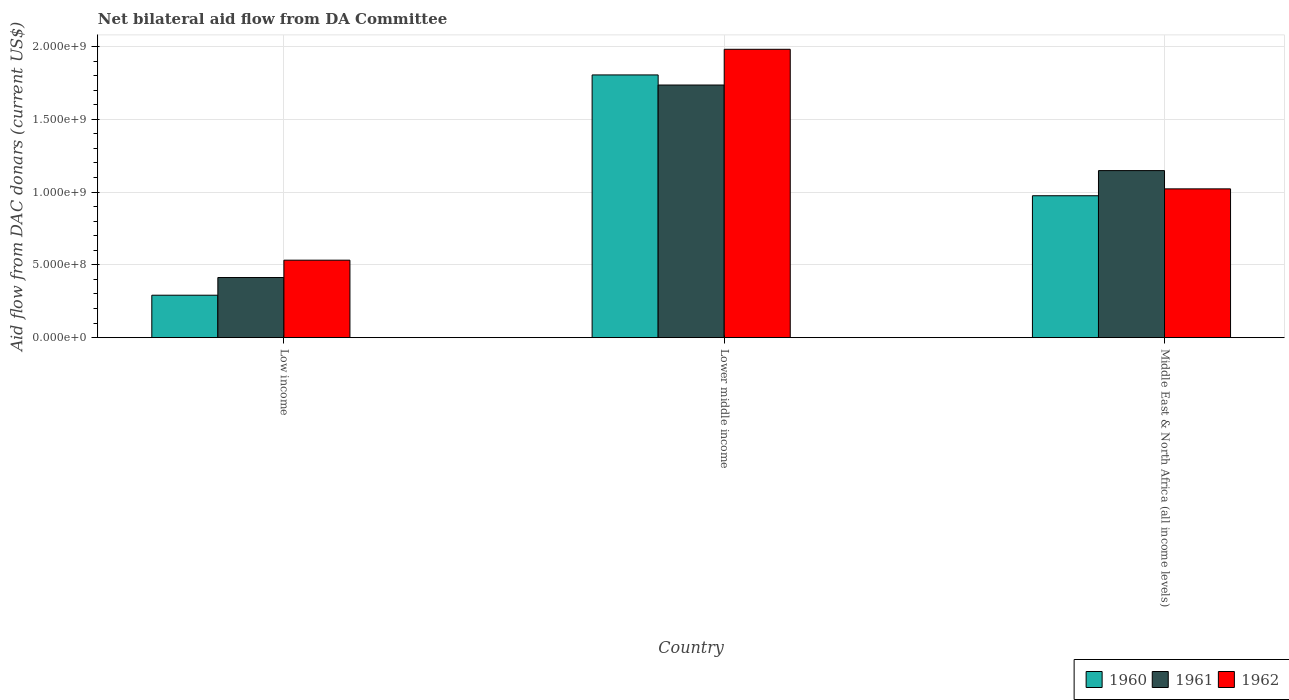How many groups of bars are there?
Your answer should be very brief. 3. How many bars are there on the 2nd tick from the right?
Offer a terse response. 3. What is the label of the 1st group of bars from the left?
Provide a succinct answer. Low income. What is the aid flow in in 1961 in Lower middle income?
Your response must be concise. 1.74e+09. Across all countries, what is the maximum aid flow in in 1962?
Provide a succinct answer. 1.98e+09. Across all countries, what is the minimum aid flow in in 1960?
Provide a short and direct response. 2.92e+08. In which country was the aid flow in in 1960 maximum?
Your answer should be compact. Lower middle income. In which country was the aid flow in in 1962 minimum?
Provide a short and direct response. Low income. What is the total aid flow in in 1962 in the graph?
Give a very brief answer. 3.53e+09. What is the difference between the aid flow in in 1961 in Lower middle income and that in Middle East & North Africa (all income levels)?
Ensure brevity in your answer.  5.88e+08. What is the difference between the aid flow in in 1962 in Low income and the aid flow in in 1961 in Lower middle income?
Make the answer very short. -1.20e+09. What is the average aid flow in in 1960 per country?
Your answer should be very brief. 1.02e+09. What is the difference between the aid flow in of/in 1962 and aid flow in of/in 1961 in Lower middle income?
Provide a succinct answer. 2.45e+08. What is the ratio of the aid flow in in 1962 in Lower middle income to that in Middle East & North Africa (all income levels)?
Offer a very short reply. 1.94. Is the aid flow in in 1961 in Low income less than that in Middle East & North Africa (all income levels)?
Give a very brief answer. Yes. What is the difference between the highest and the second highest aid flow in in 1960?
Keep it short and to the point. 8.30e+08. What is the difference between the highest and the lowest aid flow in in 1962?
Make the answer very short. 1.45e+09. What does the 2nd bar from the left in Middle East & North Africa (all income levels) represents?
Keep it short and to the point. 1961. What does the 2nd bar from the right in Lower middle income represents?
Keep it short and to the point. 1961. Is it the case that in every country, the sum of the aid flow in in 1962 and aid flow in in 1960 is greater than the aid flow in in 1961?
Provide a short and direct response. Yes. How many bars are there?
Your answer should be compact. 9. Are all the bars in the graph horizontal?
Offer a terse response. No. What is the difference between two consecutive major ticks on the Y-axis?
Your answer should be compact. 5.00e+08. Are the values on the major ticks of Y-axis written in scientific E-notation?
Make the answer very short. Yes. Does the graph contain any zero values?
Keep it short and to the point. No. Where does the legend appear in the graph?
Provide a short and direct response. Bottom right. How many legend labels are there?
Give a very brief answer. 3. What is the title of the graph?
Give a very brief answer. Net bilateral aid flow from DA Committee. What is the label or title of the Y-axis?
Keep it short and to the point. Aid flow from DAC donars (current US$). What is the Aid flow from DAC donars (current US$) in 1960 in Low income?
Your answer should be compact. 2.92e+08. What is the Aid flow from DAC donars (current US$) in 1961 in Low income?
Make the answer very short. 4.13e+08. What is the Aid flow from DAC donars (current US$) in 1962 in Low income?
Give a very brief answer. 5.32e+08. What is the Aid flow from DAC donars (current US$) in 1960 in Lower middle income?
Offer a very short reply. 1.80e+09. What is the Aid flow from DAC donars (current US$) of 1961 in Lower middle income?
Offer a very short reply. 1.74e+09. What is the Aid flow from DAC donars (current US$) in 1962 in Lower middle income?
Your answer should be compact. 1.98e+09. What is the Aid flow from DAC donars (current US$) in 1960 in Middle East & North Africa (all income levels)?
Make the answer very short. 9.75e+08. What is the Aid flow from DAC donars (current US$) in 1961 in Middle East & North Africa (all income levels)?
Offer a very short reply. 1.15e+09. What is the Aid flow from DAC donars (current US$) of 1962 in Middle East & North Africa (all income levels)?
Your response must be concise. 1.02e+09. Across all countries, what is the maximum Aid flow from DAC donars (current US$) in 1960?
Your answer should be compact. 1.80e+09. Across all countries, what is the maximum Aid flow from DAC donars (current US$) in 1961?
Your answer should be very brief. 1.74e+09. Across all countries, what is the maximum Aid flow from DAC donars (current US$) in 1962?
Offer a very short reply. 1.98e+09. Across all countries, what is the minimum Aid flow from DAC donars (current US$) in 1960?
Keep it short and to the point. 2.92e+08. Across all countries, what is the minimum Aid flow from DAC donars (current US$) of 1961?
Your answer should be very brief. 4.13e+08. Across all countries, what is the minimum Aid flow from DAC donars (current US$) in 1962?
Provide a short and direct response. 5.32e+08. What is the total Aid flow from DAC donars (current US$) of 1960 in the graph?
Your response must be concise. 3.07e+09. What is the total Aid flow from DAC donars (current US$) in 1961 in the graph?
Ensure brevity in your answer.  3.30e+09. What is the total Aid flow from DAC donars (current US$) of 1962 in the graph?
Provide a succinct answer. 3.53e+09. What is the difference between the Aid flow from DAC donars (current US$) in 1960 in Low income and that in Lower middle income?
Your answer should be compact. -1.51e+09. What is the difference between the Aid flow from DAC donars (current US$) of 1961 in Low income and that in Lower middle income?
Ensure brevity in your answer.  -1.32e+09. What is the difference between the Aid flow from DAC donars (current US$) in 1962 in Low income and that in Lower middle income?
Ensure brevity in your answer.  -1.45e+09. What is the difference between the Aid flow from DAC donars (current US$) of 1960 in Low income and that in Middle East & North Africa (all income levels)?
Your response must be concise. -6.83e+08. What is the difference between the Aid flow from DAC donars (current US$) in 1961 in Low income and that in Middle East & North Africa (all income levels)?
Your response must be concise. -7.34e+08. What is the difference between the Aid flow from DAC donars (current US$) in 1962 in Low income and that in Middle East & North Africa (all income levels)?
Keep it short and to the point. -4.90e+08. What is the difference between the Aid flow from DAC donars (current US$) in 1960 in Lower middle income and that in Middle East & North Africa (all income levels)?
Your answer should be compact. 8.30e+08. What is the difference between the Aid flow from DAC donars (current US$) in 1961 in Lower middle income and that in Middle East & North Africa (all income levels)?
Your answer should be very brief. 5.88e+08. What is the difference between the Aid flow from DAC donars (current US$) in 1962 in Lower middle income and that in Middle East & North Africa (all income levels)?
Your answer should be very brief. 9.59e+08. What is the difference between the Aid flow from DAC donars (current US$) of 1960 in Low income and the Aid flow from DAC donars (current US$) of 1961 in Lower middle income?
Ensure brevity in your answer.  -1.44e+09. What is the difference between the Aid flow from DAC donars (current US$) in 1960 in Low income and the Aid flow from DAC donars (current US$) in 1962 in Lower middle income?
Provide a short and direct response. -1.69e+09. What is the difference between the Aid flow from DAC donars (current US$) in 1961 in Low income and the Aid flow from DAC donars (current US$) in 1962 in Lower middle income?
Give a very brief answer. -1.57e+09. What is the difference between the Aid flow from DAC donars (current US$) in 1960 in Low income and the Aid flow from DAC donars (current US$) in 1961 in Middle East & North Africa (all income levels)?
Keep it short and to the point. -8.56e+08. What is the difference between the Aid flow from DAC donars (current US$) in 1960 in Low income and the Aid flow from DAC donars (current US$) in 1962 in Middle East & North Africa (all income levels)?
Provide a succinct answer. -7.30e+08. What is the difference between the Aid flow from DAC donars (current US$) in 1961 in Low income and the Aid flow from DAC donars (current US$) in 1962 in Middle East & North Africa (all income levels)?
Your response must be concise. -6.09e+08. What is the difference between the Aid flow from DAC donars (current US$) of 1960 in Lower middle income and the Aid flow from DAC donars (current US$) of 1961 in Middle East & North Africa (all income levels)?
Offer a terse response. 6.57e+08. What is the difference between the Aid flow from DAC donars (current US$) in 1960 in Lower middle income and the Aid flow from DAC donars (current US$) in 1962 in Middle East & North Africa (all income levels)?
Your answer should be very brief. 7.83e+08. What is the difference between the Aid flow from DAC donars (current US$) in 1961 in Lower middle income and the Aid flow from DAC donars (current US$) in 1962 in Middle East & North Africa (all income levels)?
Provide a short and direct response. 7.13e+08. What is the average Aid flow from DAC donars (current US$) in 1960 per country?
Your answer should be very brief. 1.02e+09. What is the average Aid flow from DAC donars (current US$) in 1961 per country?
Provide a succinct answer. 1.10e+09. What is the average Aid flow from DAC donars (current US$) of 1962 per country?
Your answer should be very brief. 1.18e+09. What is the difference between the Aid flow from DAC donars (current US$) of 1960 and Aid flow from DAC donars (current US$) of 1961 in Low income?
Ensure brevity in your answer.  -1.21e+08. What is the difference between the Aid flow from DAC donars (current US$) in 1960 and Aid flow from DAC donars (current US$) in 1962 in Low income?
Your response must be concise. -2.41e+08. What is the difference between the Aid flow from DAC donars (current US$) of 1961 and Aid flow from DAC donars (current US$) of 1962 in Low income?
Offer a terse response. -1.19e+08. What is the difference between the Aid flow from DAC donars (current US$) of 1960 and Aid flow from DAC donars (current US$) of 1961 in Lower middle income?
Provide a succinct answer. 6.93e+07. What is the difference between the Aid flow from DAC donars (current US$) of 1960 and Aid flow from DAC donars (current US$) of 1962 in Lower middle income?
Offer a terse response. -1.76e+08. What is the difference between the Aid flow from DAC donars (current US$) of 1961 and Aid flow from DAC donars (current US$) of 1962 in Lower middle income?
Offer a terse response. -2.45e+08. What is the difference between the Aid flow from DAC donars (current US$) of 1960 and Aid flow from DAC donars (current US$) of 1961 in Middle East & North Africa (all income levels)?
Ensure brevity in your answer.  -1.73e+08. What is the difference between the Aid flow from DAC donars (current US$) of 1960 and Aid flow from DAC donars (current US$) of 1962 in Middle East & North Africa (all income levels)?
Your answer should be very brief. -4.72e+07. What is the difference between the Aid flow from DAC donars (current US$) in 1961 and Aid flow from DAC donars (current US$) in 1962 in Middle East & North Africa (all income levels)?
Ensure brevity in your answer.  1.25e+08. What is the ratio of the Aid flow from DAC donars (current US$) of 1960 in Low income to that in Lower middle income?
Provide a succinct answer. 0.16. What is the ratio of the Aid flow from DAC donars (current US$) of 1961 in Low income to that in Lower middle income?
Ensure brevity in your answer.  0.24. What is the ratio of the Aid flow from DAC donars (current US$) in 1962 in Low income to that in Lower middle income?
Your response must be concise. 0.27. What is the ratio of the Aid flow from DAC donars (current US$) of 1960 in Low income to that in Middle East & North Africa (all income levels)?
Provide a short and direct response. 0.3. What is the ratio of the Aid flow from DAC donars (current US$) of 1961 in Low income to that in Middle East & North Africa (all income levels)?
Offer a terse response. 0.36. What is the ratio of the Aid flow from DAC donars (current US$) in 1962 in Low income to that in Middle East & North Africa (all income levels)?
Your answer should be compact. 0.52. What is the ratio of the Aid flow from DAC donars (current US$) of 1960 in Lower middle income to that in Middle East & North Africa (all income levels)?
Ensure brevity in your answer.  1.85. What is the ratio of the Aid flow from DAC donars (current US$) in 1961 in Lower middle income to that in Middle East & North Africa (all income levels)?
Your answer should be compact. 1.51. What is the ratio of the Aid flow from DAC donars (current US$) in 1962 in Lower middle income to that in Middle East & North Africa (all income levels)?
Ensure brevity in your answer.  1.94. What is the difference between the highest and the second highest Aid flow from DAC donars (current US$) of 1960?
Provide a succinct answer. 8.30e+08. What is the difference between the highest and the second highest Aid flow from DAC donars (current US$) in 1961?
Your answer should be very brief. 5.88e+08. What is the difference between the highest and the second highest Aid flow from DAC donars (current US$) in 1962?
Offer a terse response. 9.59e+08. What is the difference between the highest and the lowest Aid flow from DAC donars (current US$) of 1960?
Offer a terse response. 1.51e+09. What is the difference between the highest and the lowest Aid flow from DAC donars (current US$) of 1961?
Your response must be concise. 1.32e+09. What is the difference between the highest and the lowest Aid flow from DAC donars (current US$) in 1962?
Ensure brevity in your answer.  1.45e+09. 